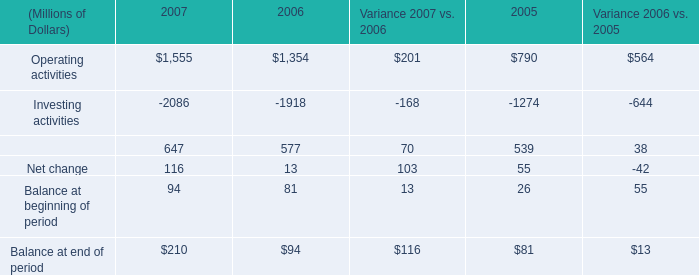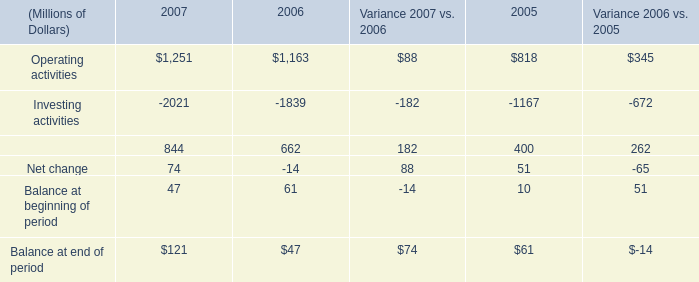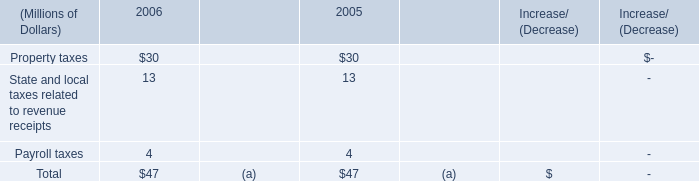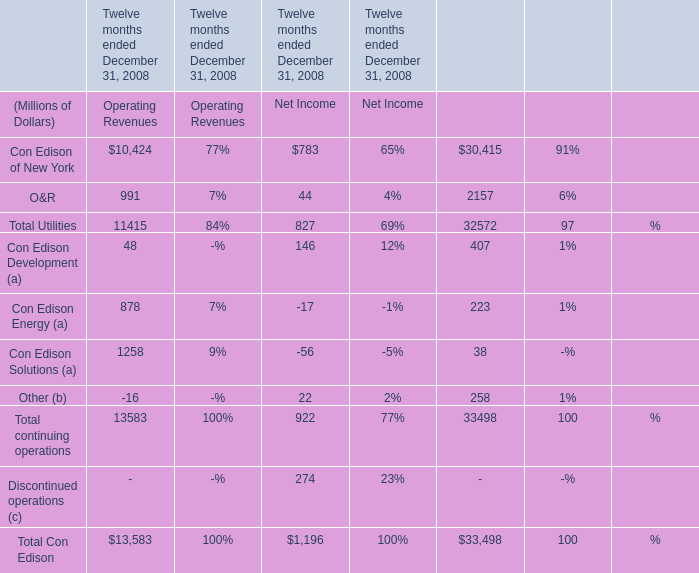What do all elements sum up for Operating Revenue , excluding Con Edison Solutions (a) and Other (b)? (in Million) 
Computations: (((10424 + 991) + 48) + 878)
Answer: 12341.0. 